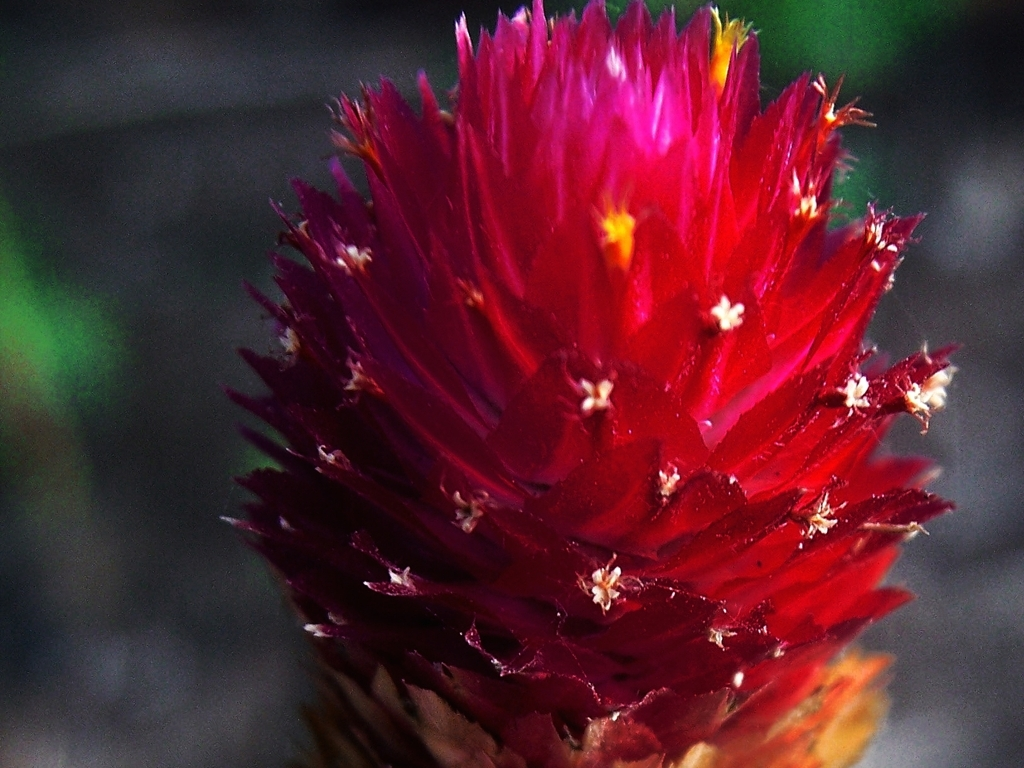What time of day does the lighting of the photo suggest? The shadows and the overall softness of the light suggest that the photo might have been taken during the golden hours, either shortly after sunrise or before sunset, when the light has a warm and gentle quality. Is there any indication of the season or particular weather conditions when this image was captured? While there are no explicit indicators of the season, the image conveys a sense of freshness and vitality commonly associated with spring or summer. The clear visibility and absence of any signs of precipitation suggest fair weather conditions during the capture. 